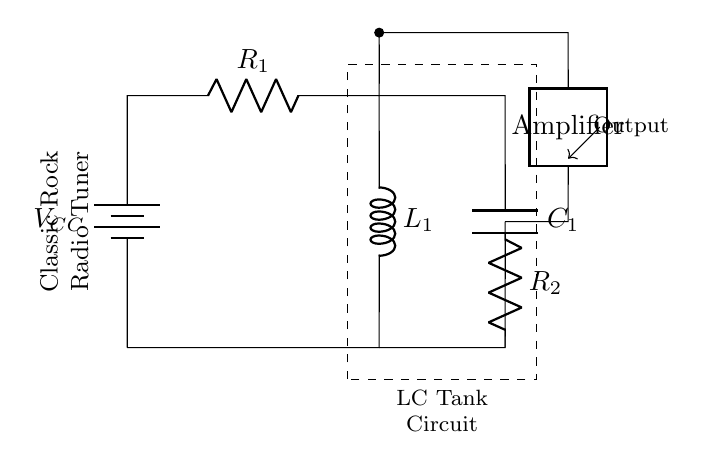What is the value of the capacitor in this circuit? The capacitor in the circuit diagram is labeled as C1. Therefore, its value can be identified directly from the labeling.
Answer: C1 What is the function of the inductor in this circuit? The inductor labeled L1 in an LC tank oscillator is responsible for storing energy in the magnetic field when current flows through it, which is essential for tuning radio frequencies.
Answer: Energy storage What type of amplifier is shown in the circuit? The circuit displays a 'twoport' amplifier, which generally serves as a gain stage, amplifying the oscillation signal produced by the LC tank circuit.
Answer: Twoport Which components are part of the LC tank circuit? The LC tank circuit is composed of the inductor L1 and the capacitor C1, which work together to create oscillations at a specific frequency.
Answer: L1 and C1 What role does the resistor R1 play in this circuit? Resistor R1 functions to limit the current flowing into the LC tank circuit, helping to control the oscillation characteristics and stability of the circuit.
Answer: Current limiter What is the total voltage supplied to the circuit? The circuit is supplied with a voltage labeled as VCC, which is the total voltage available to power the components of the oscillator circuit.
Answer: VCC Which part of the circuit outputs the oscillation signal? The output of the oscillation signal is indicated by the arrow pointing from the amplifier towards the output label, which represents where the signal is taken from the circuit.
Answer: Output 